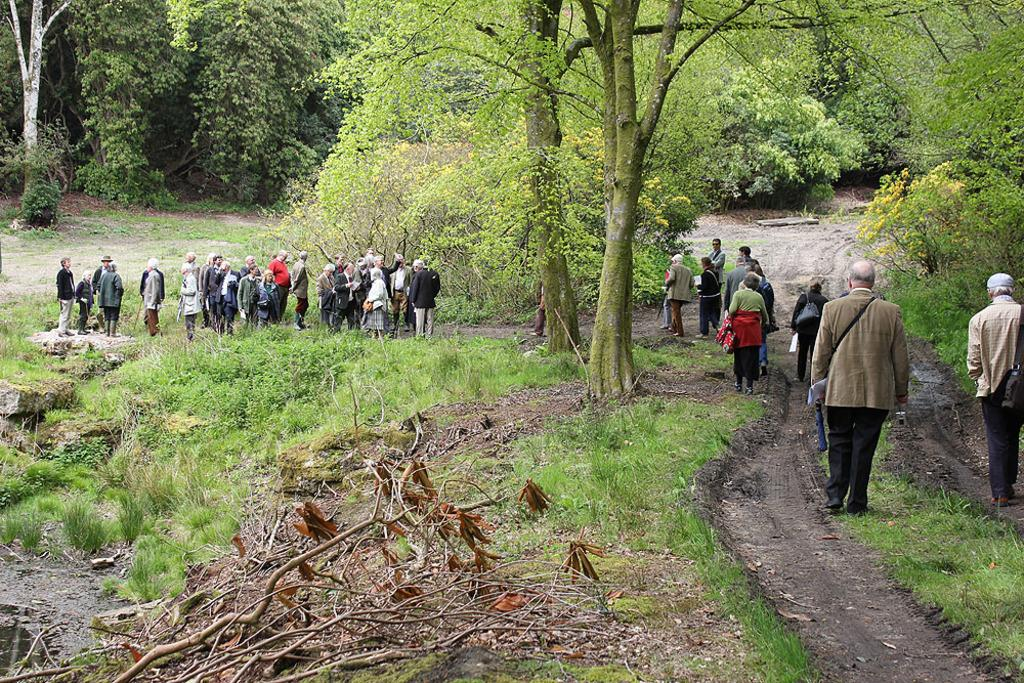How many people are in the image? There is a group of people in the image. What are some of the people in the image doing? Some people are standing, and some are walking. What can be seen in the background of the image? There are plants and trees in the background of the image. What are the hobbies of the body in the image? There is no body present in the image, and therefore no hobbies can be attributed to it. 